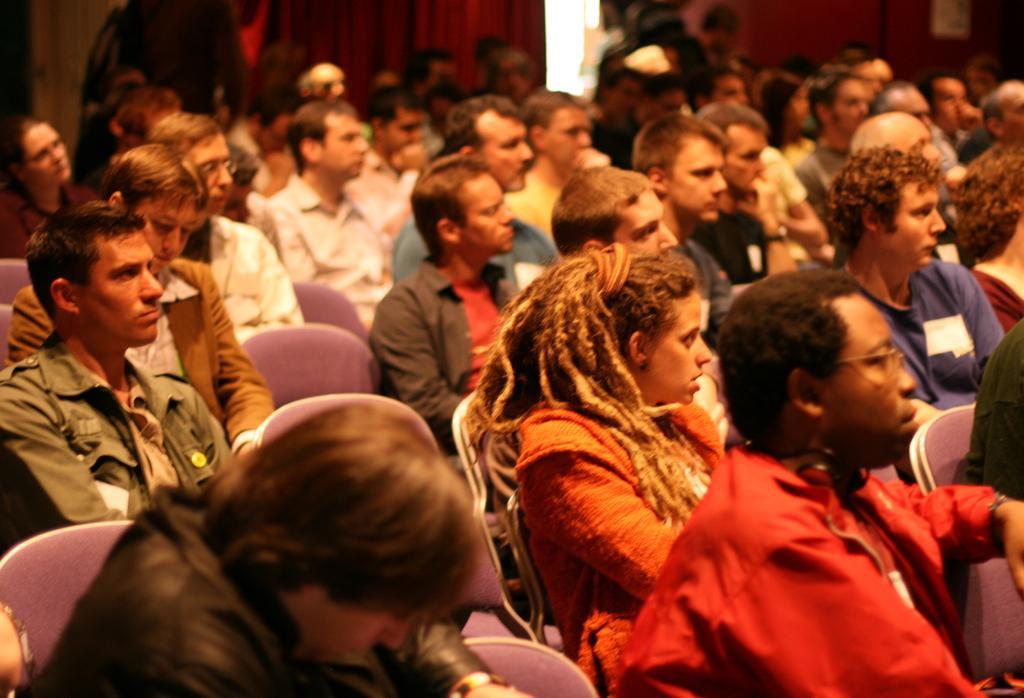Describe this image in one or two sentences. In this image I can see group of people sitting. In front the person is wearing red color dress. In the background I can see few curtains. 